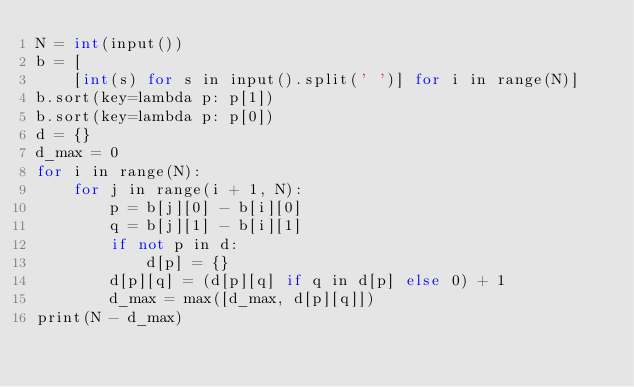<code> <loc_0><loc_0><loc_500><loc_500><_C++_>N = int(input())
b = [
    [int(s) for s in input().split(' ')] for i in range(N)]
b.sort(key=lambda p: p[1])
b.sort(key=lambda p: p[0])
d = {}
d_max = 0
for i in range(N):
    for j in range(i + 1, N):
        p = b[j][0] - b[i][0]
        q = b[j][1] - b[i][1]
        if not p in d:
            d[p] = {}
        d[p][q] = (d[p][q] if q in d[p] else 0) + 1
        d_max = max([d_max, d[p][q]])
print(N - d_max)</code> 